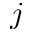Convert formula to latex. <formula><loc_0><loc_0><loc_500><loc_500>j</formula> 